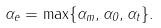Convert formula to latex. <formula><loc_0><loc_0><loc_500><loc_500>\alpha _ { e } = \max \{ \alpha _ { m } , \alpha _ { 0 } , \alpha _ { t } \} .</formula> 